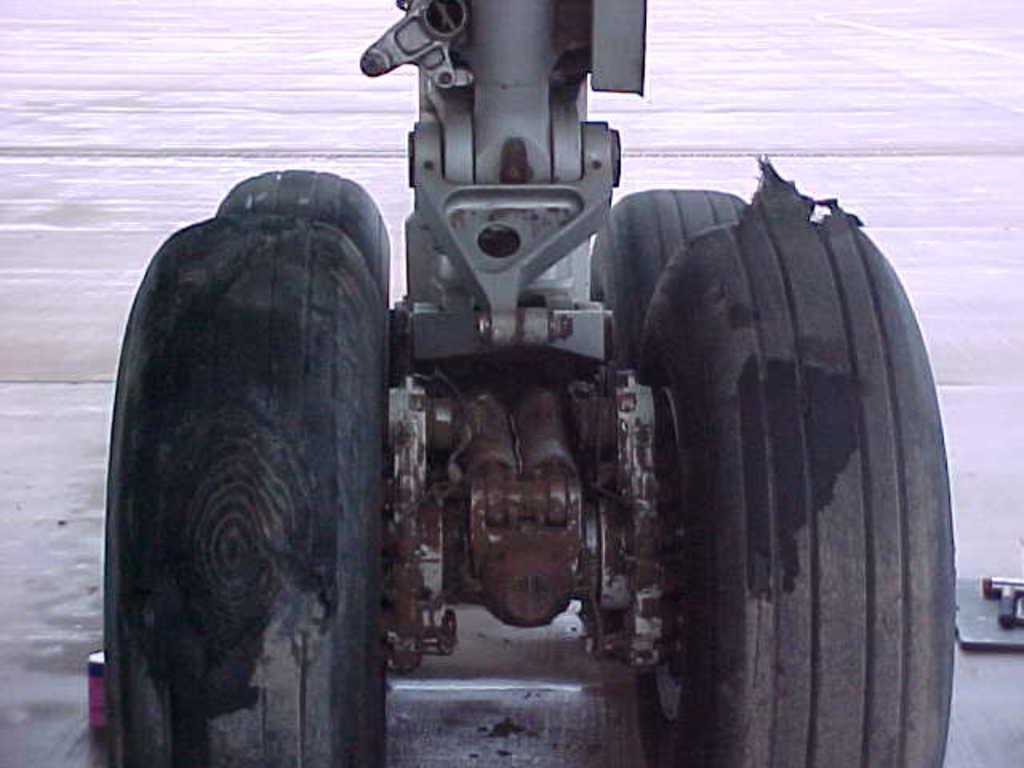Could you give a brief overview of what you see in this image? In this image I can see few wheels in black color and I can see white color background. 